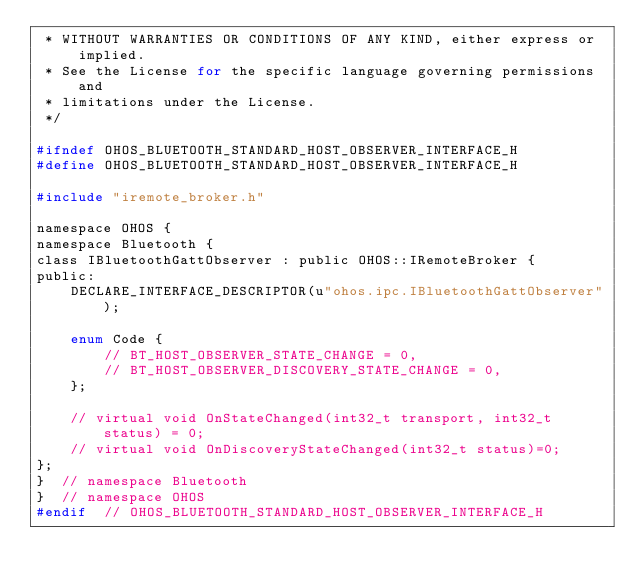Convert code to text. <code><loc_0><loc_0><loc_500><loc_500><_C_> * WITHOUT WARRANTIES OR CONDITIONS OF ANY KIND, either express or implied.
 * See the License for the specific language governing permissions and
 * limitations under the License.
 */

#ifndef OHOS_BLUETOOTH_STANDARD_HOST_OBSERVER_INTERFACE_H
#define OHOS_BLUETOOTH_STANDARD_HOST_OBSERVER_INTERFACE_H

#include "iremote_broker.h"

namespace OHOS {
namespace Bluetooth {
class IBluetoothGattObserver : public OHOS::IRemoteBroker {
public:
    DECLARE_INTERFACE_DESCRIPTOR(u"ohos.ipc.IBluetoothGattObserver");

    enum Code {
        // BT_HOST_OBSERVER_STATE_CHANGE = 0,
        // BT_HOST_OBSERVER_DISCOVERY_STATE_CHANGE = 0,
    };

    // virtual void OnStateChanged(int32_t transport, int32_t status) = 0;
    // virtual void OnDiscoveryStateChanged(int32_t status)=0;
};
}  // namespace Bluetooth
}  // namespace OHOS
#endif  // OHOS_BLUETOOTH_STANDARD_HOST_OBSERVER_INTERFACE_H</code> 